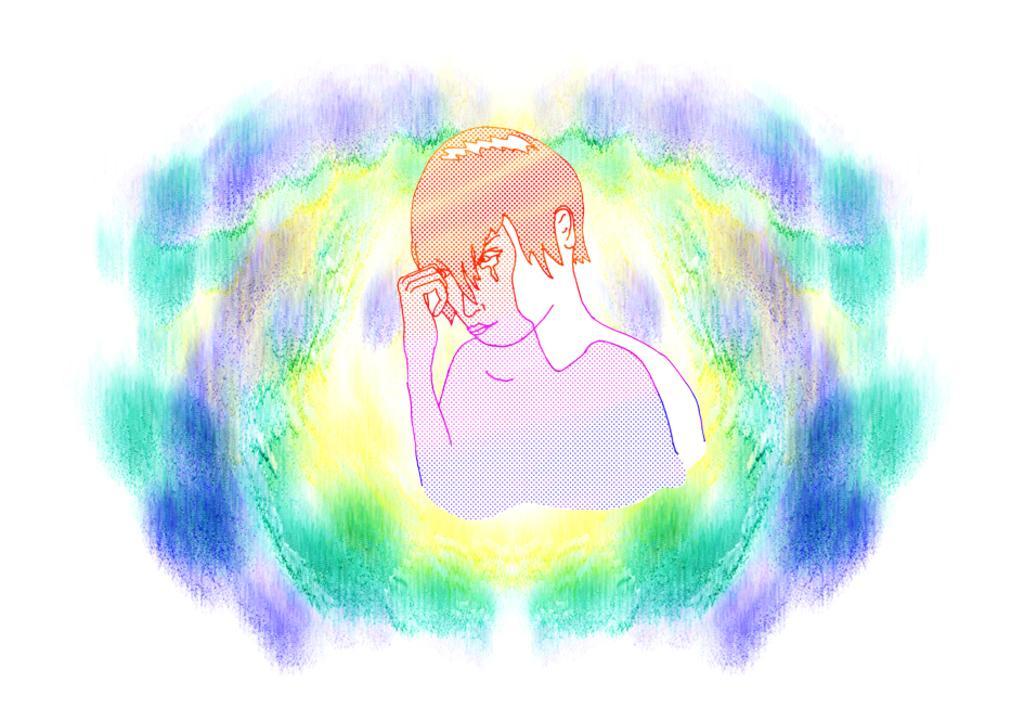Please provide a concise description of this image. This image is a painting. In this painting we can see a image of a person. 